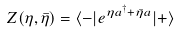<formula> <loc_0><loc_0><loc_500><loc_500>Z ( \eta , \bar { \eta } ) = \langle - | e ^ { \eta a ^ { \dagger } + \bar { \eta } a } | + \rangle</formula> 